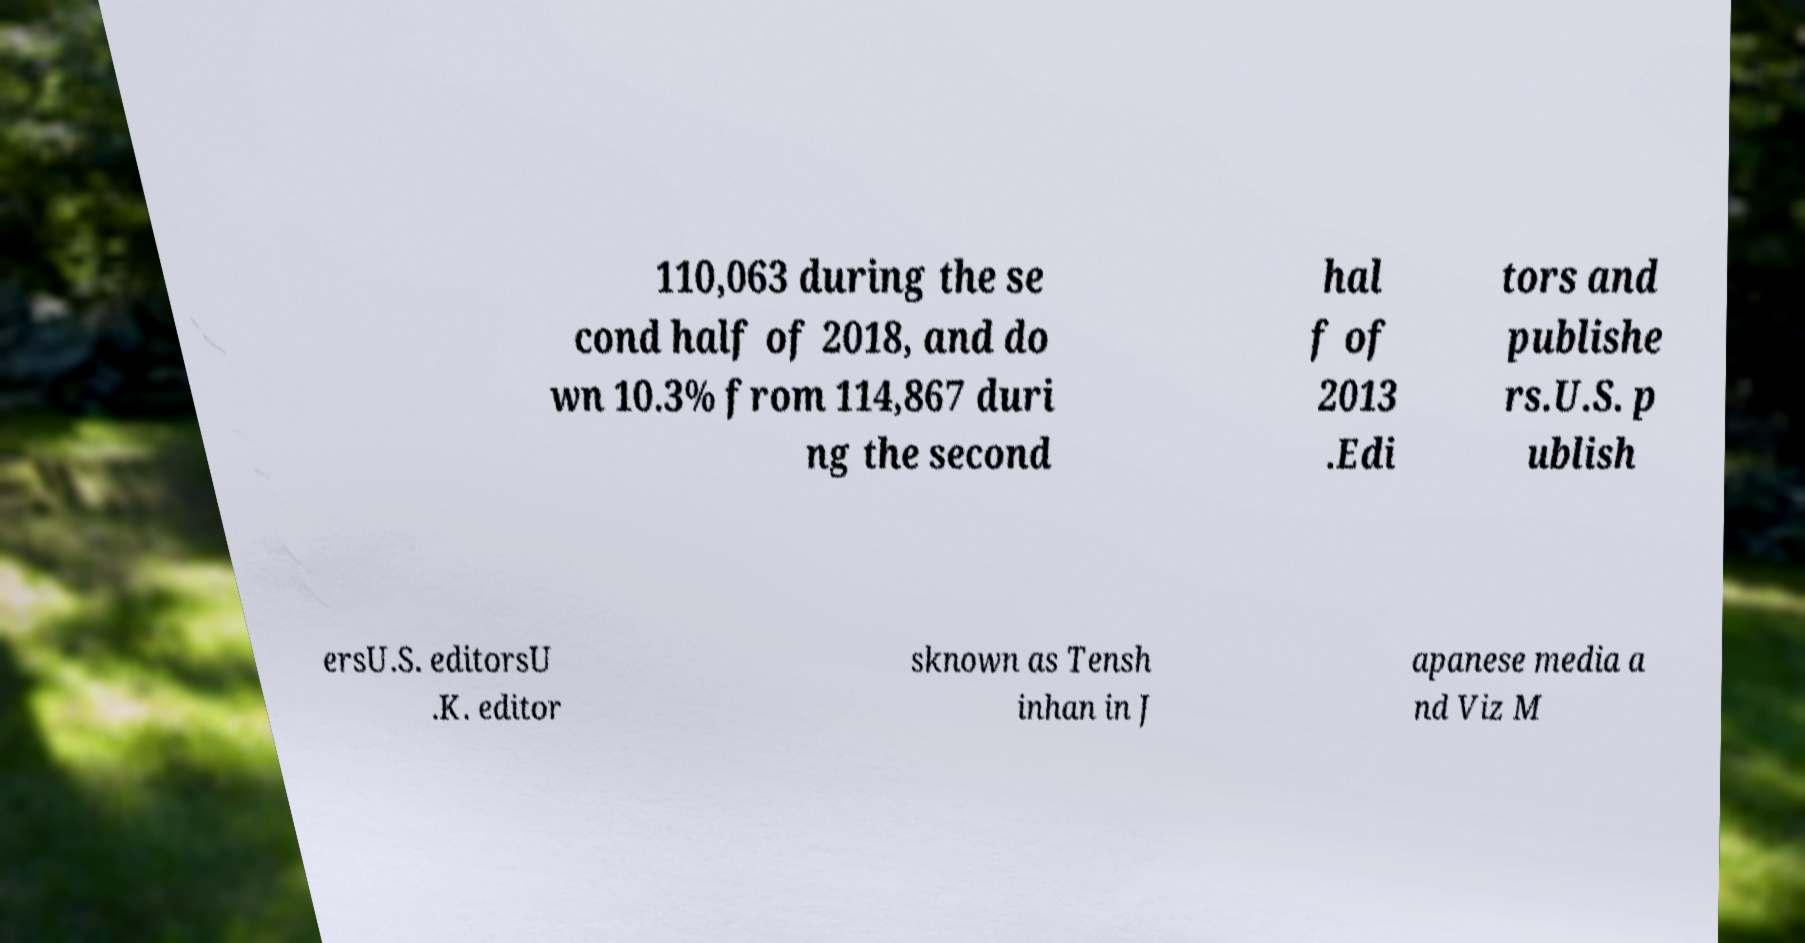There's text embedded in this image that I need extracted. Can you transcribe it verbatim? 110,063 during the se cond half of 2018, and do wn 10.3% from 114,867 duri ng the second hal f of 2013 .Edi tors and publishe rs.U.S. p ublish ersU.S. editorsU .K. editor sknown as Tensh inhan in J apanese media a nd Viz M 